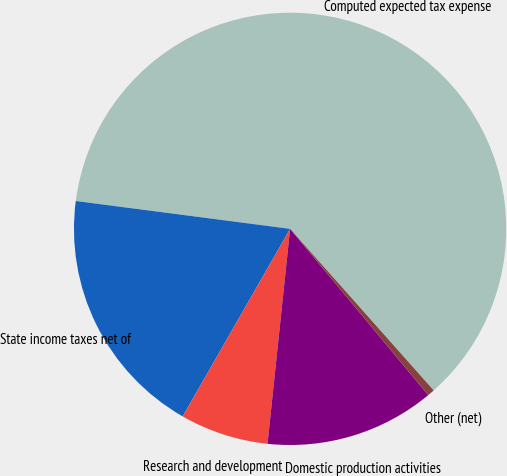Convert chart to OTSL. <chart><loc_0><loc_0><loc_500><loc_500><pie_chart><fcel>Computed expected tax expense<fcel>State income taxes net of<fcel>Research and development<fcel>Domestic production activities<fcel>Other (net)<nl><fcel>61.38%<fcel>18.78%<fcel>6.61%<fcel>12.7%<fcel>0.53%<nl></chart> 